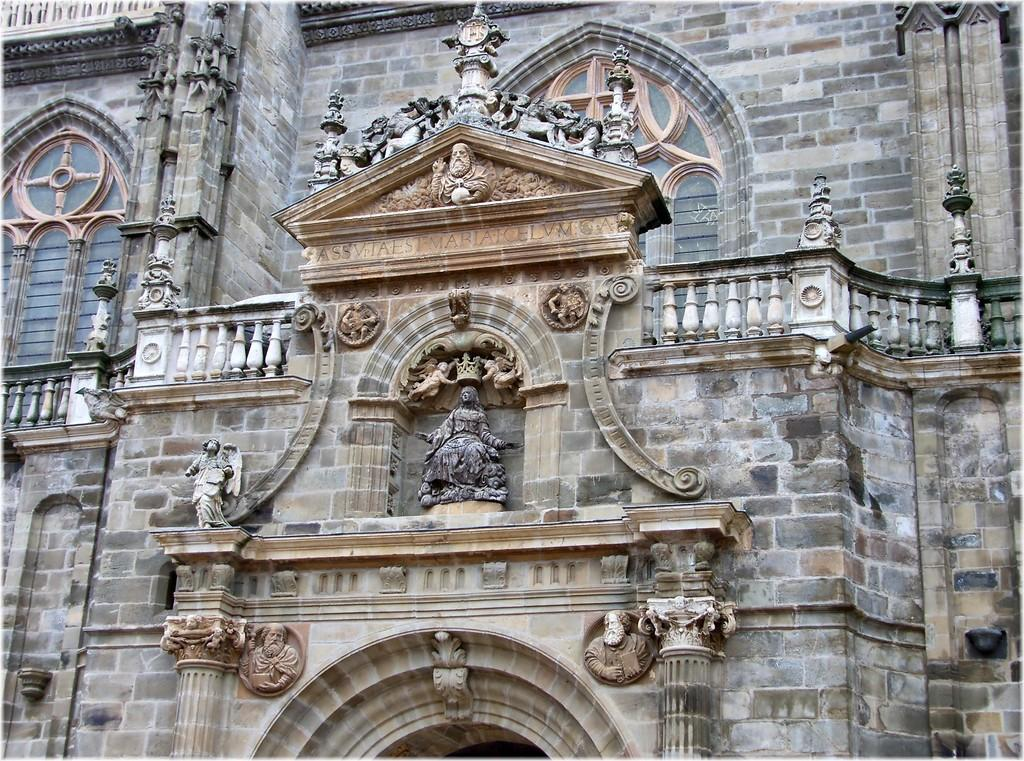What type of structure is visible in the image? There is a building in the image. What decorative elements can be seen on the building? The building has many sculptures and statues. What architectural feature is present at the bottom of the building? There is an arch at the bottom of the building, accompanied by pillars. What material is used to construct the walls of the building? The walls of the building are made of rocks. What type of rose is growing on the wrist of the bird in the image? There is no rose, wrist, or bird present in the image. 